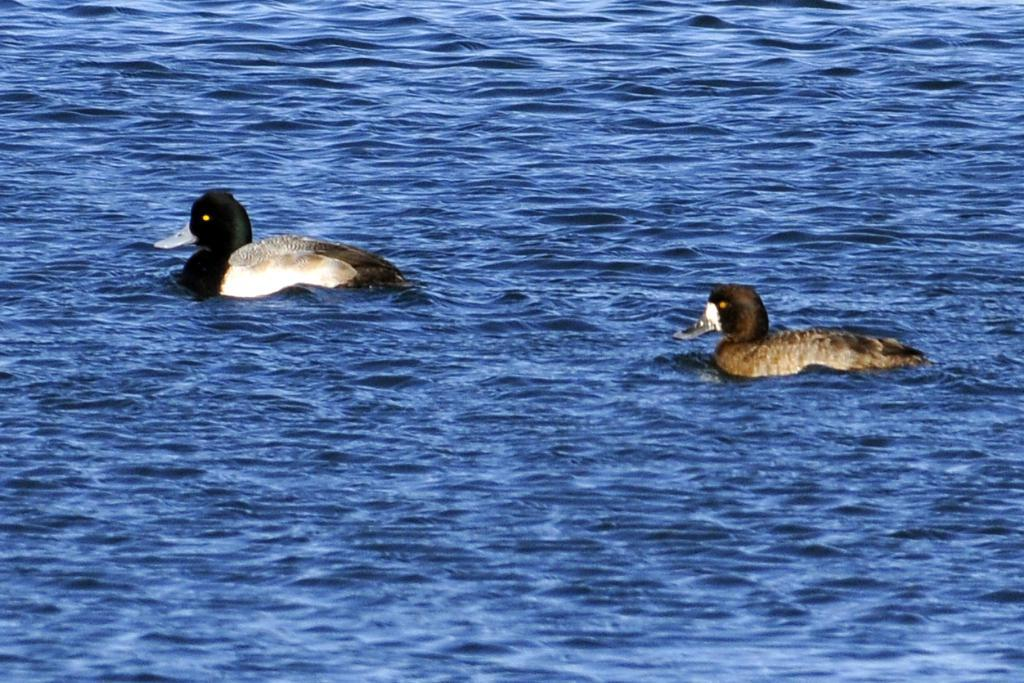How many ducks are present in the image? There are two ducks in the image. What are the ducks doing in the image? The ducks are swimming in the water. What type of environment is depicted in the image? The image shows water, which might be in a river. What type of hook can be seen attached to the goat in the image? There is no goat or hook present in the image; it features two ducks swimming in water. Is the box visible in the image? There is no box present in the image; it only shows two ducks swimming in water. 